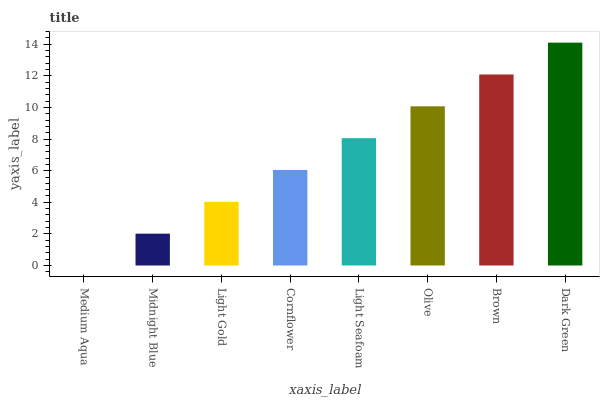Is Medium Aqua the minimum?
Answer yes or no. Yes. Is Dark Green the maximum?
Answer yes or no. Yes. Is Midnight Blue the minimum?
Answer yes or no. No. Is Midnight Blue the maximum?
Answer yes or no. No. Is Midnight Blue greater than Medium Aqua?
Answer yes or no. Yes. Is Medium Aqua less than Midnight Blue?
Answer yes or no. Yes. Is Medium Aqua greater than Midnight Blue?
Answer yes or no. No. Is Midnight Blue less than Medium Aqua?
Answer yes or no. No. Is Light Seafoam the high median?
Answer yes or no. Yes. Is Cornflower the low median?
Answer yes or no. Yes. Is Medium Aqua the high median?
Answer yes or no. No. Is Light Seafoam the low median?
Answer yes or no. No. 